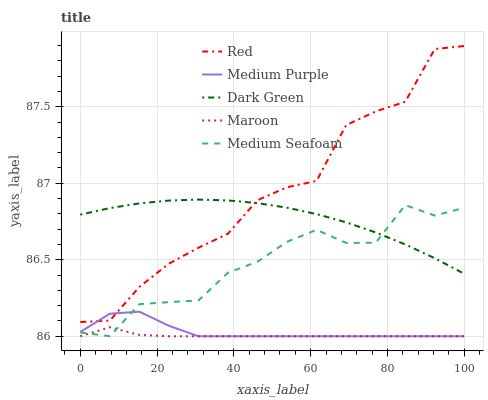Does Maroon have the minimum area under the curve?
Answer yes or no. Yes. Does Red have the maximum area under the curve?
Answer yes or no. Yes. Does Medium Seafoam have the minimum area under the curve?
Answer yes or no. No. Does Medium Seafoam have the maximum area under the curve?
Answer yes or no. No. Is Dark Green the smoothest?
Answer yes or no. Yes. Is Red the roughest?
Answer yes or no. Yes. Is Medium Seafoam the smoothest?
Answer yes or no. No. Is Medium Seafoam the roughest?
Answer yes or no. No. Does Red have the lowest value?
Answer yes or no. No. Does Medium Seafoam have the highest value?
Answer yes or no. No. Is Medium Seafoam less than Red?
Answer yes or no. Yes. Is Dark Green greater than Maroon?
Answer yes or no. Yes. Does Medium Seafoam intersect Red?
Answer yes or no. No. 